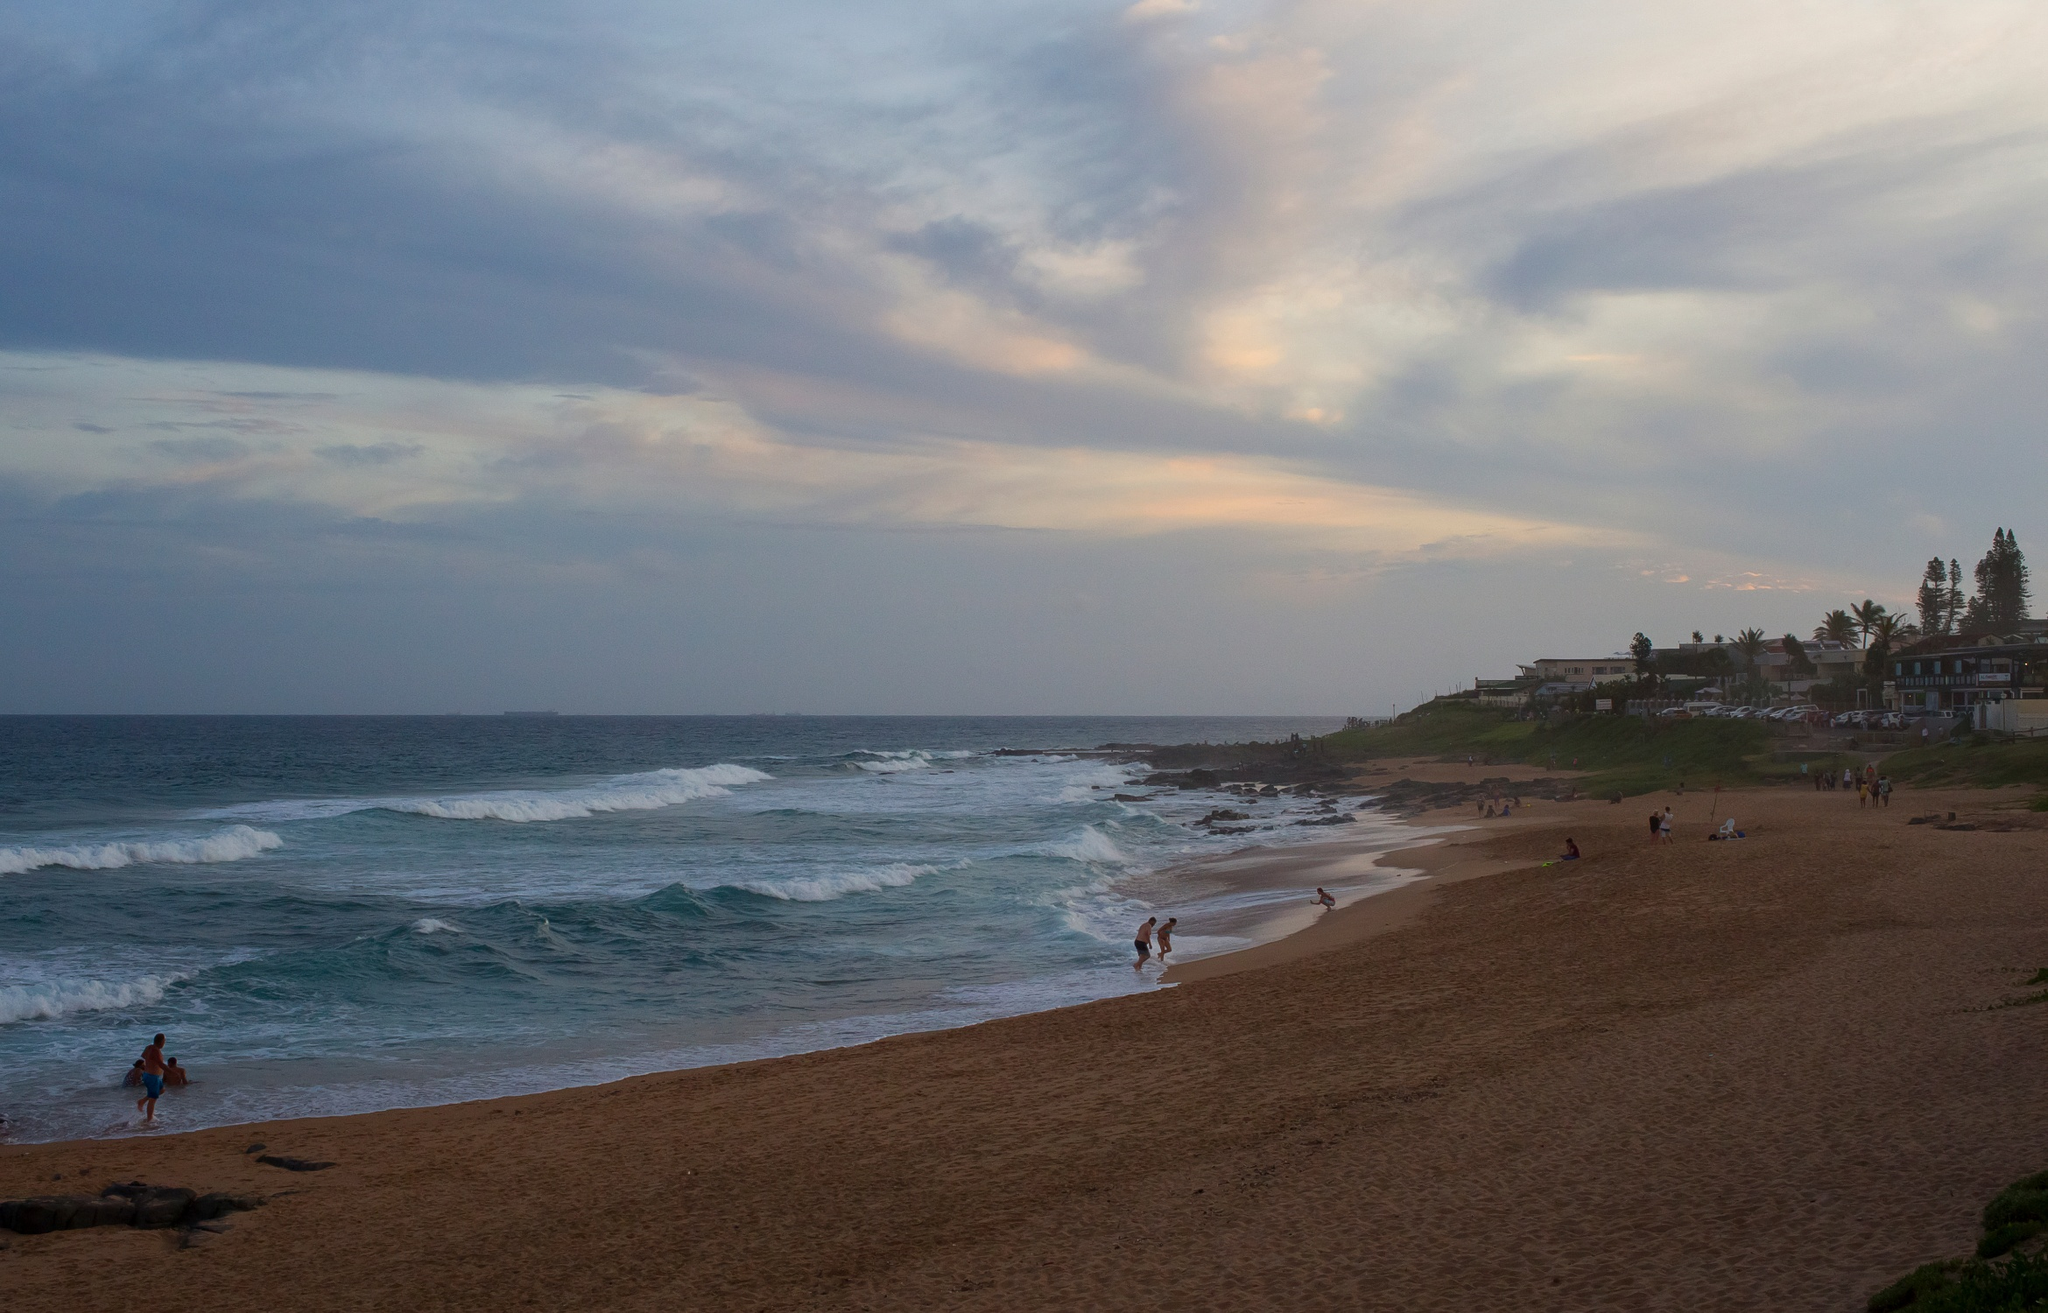If you could transform this beach into a different season, what would it look like in winter? In winter, this beach would have a very different appearance and atmosphere. The sky might be overcast with thick, gray clouds, and the ocean a darker, more tumultuous blue. The waves could be larger and more forceful, crashing onto the shore with a sense of vigor. The beach itself might be emptier, with fewer people braving the cold winds. The houses on the cliff might have smoke rising from their chimneys, indicating cozy fires inside. The vegetation would appear more subdued, perhaps with some of the more sensitive plants having gone dormant. Despite the chill, the beauty of the beach would remain, offering a stark, serene winter landscape different from its usual sunny warmth. What fantastical event could happen on this beach? Imagine a fantastical event where, during twilight, the beach suddenly begins to glow with a magical luminescence. The waves turn to shimmering silver, and the sand starts to sparkle as though embedded with countless tiny stars. As the sun dips below the horizon, mythical sea creatures such as mermaids and water dragons emerge from the ocean, their scales reflecting the iridescent light. The trees on the cliff whisper ancient secrets, and the houses reveal hidden doors leading to enchanted realms. The air is filled with the soft sound of ethereal music, drawing curious onlookers from the shore to witness this once-in-a-lifetime, otherworldly spectacle. 